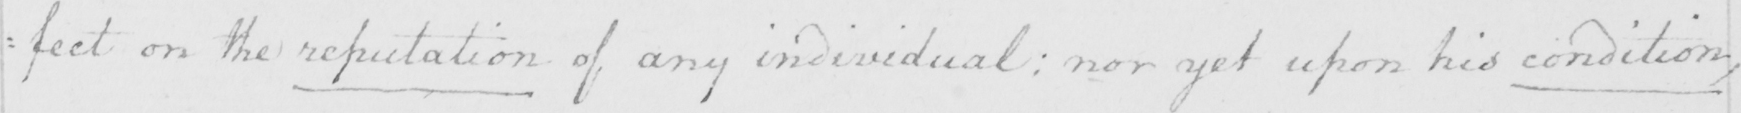What text is written in this handwritten line? =fect on the reputation of any individual :  nor yet upon his condition , 